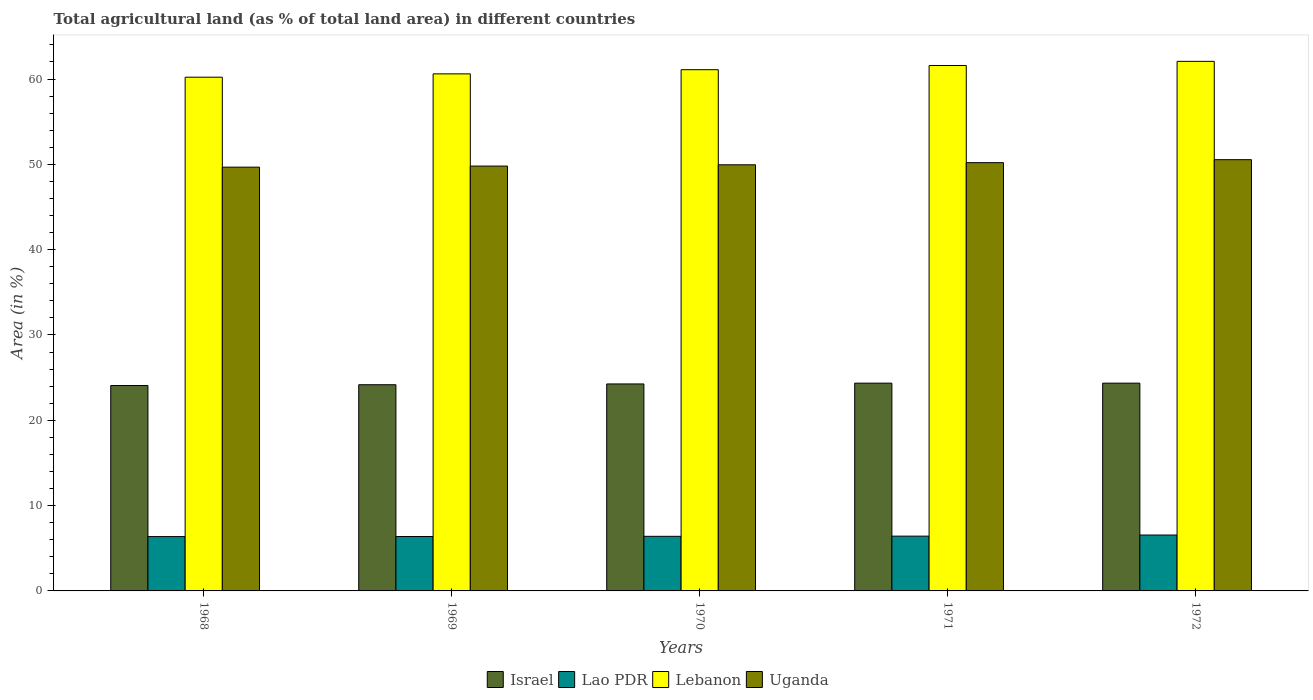How many groups of bars are there?
Provide a succinct answer. 5. Are the number of bars on each tick of the X-axis equal?
Offer a very short reply. Yes. How many bars are there on the 4th tick from the left?
Ensure brevity in your answer.  4. How many bars are there on the 5th tick from the right?
Your response must be concise. 4. In how many cases, is the number of bars for a given year not equal to the number of legend labels?
Offer a terse response. 0. What is the percentage of agricultural land in Uganda in 1972?
Give a very brief answer. 50.55. Across all years, what is the maximum percentage of agricultural land in Israel?
Give a very brief answer. 24.35. Across all years, what is the minimum percentage of agricultural land in Uganda?
Keep it short and to the point. 49.67. In which year was the percentage of agricultural land in Uganda maximum?
Your response must be concise. 1972. In which year was the percentage of agricultural land in Lebanon minimum?
Offer a very short reply. 1968. What is the total percentage of agricultural land in Israel in the graph?
Offer a very short reply. 121.21. What is the difference between the percentage of agricultural land in Israel in 1969 and that in 1970?
Offer a terse response. -0.09. What is the difference between the percentage of agricultural land in Lao PDR in 1968 and the percentage of agricultural land in Lebanon in 1969?
Your answer should be very brief. -54.24. What is the average percentage of agricultural land in Lao PDR per year?
Give a very brief answer. 6.42. In the year 1969, what is the difference between the percentage of agricultural land in Uganda and percentage of agricultural land in Lebanon?
Provide a succinct answer. -10.81. In how many years, is the percentage of agricultural land in Uganda greater than 58 %?
Give a very brief answer. 0. What is the ratio of the percentage of agricultural land in Israel in 1969 to that in 1971?
Provide a succinct answer. 0.99. Is the percentage of agricultural land in Lao PDR in 1968 less than that in 1969?
Offer a terse response. Yes. Is the difference between the percentage of agricultural land in Uganda in 1968 and 1972 greater than the difference between the percentage of agricultural land in Lebanon in 1968 and 1972?
Offer a very short reply. Yes. What is the difference between the highest and the second highest percentage of agricultural land in Uganda?
Your answer should be very brief. 0.35. What is the difference between the highest and the lowest percentage of agricultural land in Israel?
Give a very brief answer. 0.28. In how many years, is the percentage of agricultural land in Lao PDR greater than the average percentage of agricultural land in Lao PDR taken over all years?
Keep it short and to the point. 1. Is the sum of the percentage of agricultural land in Lebanon in 1968 and 1970 greater than the maximum percentage of agricultural land in Israel across all years?
Ensure brevity in your answer.  Yes. What does the 1st bar from the right in 1969 represents?
Keep it short and to the point. Uganda. Is it the case that in every year, the sum of the percentage of agricultural land in Israel and percentage of agricultural land in Lebanon is greater than the percentage of agricultural land in Uganda?
Your answer should be very brief. Yes. How many years are there in the graph?
Make the answer very short. 5. Are the values on the major ticks of Y-axis written in scientific E-notation?
Your response must be concise. No. Does the graph contain any zero values?
Your response must be concise. No. What is the title of the graph?
Ensure brevity in your answer.  Total agricultural land (as % of total land area) in different countries. Does "Middle income" appear as one of the legend labels in the graph?
Offer a very short reply. No. What is the label or title of the Y-axis?
Make the answer very short. Area (in %). What is the Area (in %) in Israel in 1968?
Your answer should be very brief. 24.08. What is the Area (in %) in Lao PDR in 1968?
Provide a short and direct response. 6.37. What is the Area (in %) of Lebanon in 1968?
Your answer should be very brief. 60.22. What is the Area (in %) of Uganda in 1968?
Provide a short and direct response. 49.67. What is the Area (in %) of Israel in 1969?
Give a very brief answer. 24.17. What is the Area (in %) in Lao PDR in 1969?
Make the answer very short. 6.38. What is the Area (in %) in Lebanon in 1969?
Offer a terse response. 60.61. What is the Area (in %) of Uganda in 1969?
Provide a succinct answer. 49.8. What is the Area (in %) of Israel in 1970?
Make the answer very short. 24.26. What is the Area (in %) of Lao PDR in 1970?
Provide a succinct answer. 6.4. What is the Area (in %) in Lebanon in 1970?
Make the answer very short. 61.09. What is the Area (in %) of Uganda in 1970?
Give a very brief answer. 49.95. What is the Area (in %) of Israel in 1971?
Keep it short and to the point. 24.35. What is the Area (in %) of Lao PDR in 1971?
Your response must be concise. 6.42. What is the Area (in %) in Lebanon in 1971?
Your response must be concise. 61.58. What is the Area (in %) of Uganda in 1971?
Give a very brief answer. 50.2. What is the Area (in %) in Israel in 1972?
Offer a terse response. 24.35. What is the Area (in %) of Lao PDR in 1972?
Your answer should be compact. 6.55. What is the Area (in %) of Lebanon in 1972?
Keep it short and to the point. 62.07. What is the Area (in %) in Uganda in 1972?
Your response must be concise. 50.55. Across all years, what is the maximum Area (in %) of Israel?
Provide a short and direct response. 24.35. Across all years, what is the maximum Area (in %) in Lao PDR?
Your answer should be very brief. 6.55. Across all years, what is the maximum Area (in %) in Lebanon?
Give a very brief answer. 62.07. Across all years, what is the maximum Area (in %) in Uganda?
Give a very brief answer. 50.55. Across all years, what is the minimum Area (in %) of Israel?
Your answer should be very brief. 24.08. Across all years, what is the minimum Area (in %) in Lao PDR?
Your response must be concise. 6.37. Across all years, what is the minimum Area (in %) in Lebanon?
Offer a very short reply. 60.22. Across all years, what is the minimum Area (in %) in Uganda?
Provide a short and direct response. 49.67. What is the total Area (in %) in Israel in the graph?
Offer a terse response. 121.21. What is the total Area (in %) in Lao PDR in the graph?
Make the answer very short. 32.12. What is the total Area (in %) in Lebanon in the graph?
Your response must be concise. 305.57. What is the total Area (in %) of Uganda in the graph?
Give a very brief answer. 250.16. What is the difference between the Area (in %) of Israel in 1968 and that in 1969?
Provide a succinct answer. -0.09. What is the difference between the Area (in %) in Lao PDR in 1968 and that in 1969?
Make the answer very short. -0.01. What is the difference between the Area (in %) of Lebanon in 1968 and that in 1969?
Provide a succinct answer. -0.39. What is the difference between the Area (in %) of Uganda in 1968 and that in 1969?
Ensure brevity in your answer.  -0.13. What is the difference between the Area (in %) in Israel in 1968 and that in 1970?
Offer a very short reply. -0.18. What is the difference between the Area (in %) of Lao PDR in 1968 and that in 1970?
Provide a short and direct response. -0.03. What is the difference between the Area (in %) in Lebanon in 1968 and that in 1970?
Your response must be concise. -0.88. What is the difference between the Area (in %) in Uganda in 1968 and that in 1970?
Provide a succinct answer. -0.28. What is the difference between the Area (in %) in Israel in 1968 and that in 1971?
Your answer should be compact. -0.28. What is the difference between the Area (in %) in Lao PDR in 1968 and that in 1971?
Make the answer very short. -0.05. What is the difference between the Area (in %) of Lebanon in 1968 and that in 1971?
Offer a terse response. -1.37. What is the difference between the Area (in %) in Uganda in 1968 and that in 1971?
Provide a succinct answer. -0.53. What is the difference between the Area (in %) in Israel in 1968 and that in 1972?
Your answer should be very brief. -0.28. What is the difference between the Area (in %) of Lao PDR in 1968 and that in 1972?
Your answer should be very brief. -0.18. What is the difference between the Area (in %) of Lebanon in 1968 and that in 1972?
Ensure brevity in your answer.  -1.86. What is the difference between the Area (in %) in Uganda in 1968 and that in 1972?
Offer a very short reply. -0.88. What is the difference between the Area (in %) in Israel in 1969 and that in 1970?
Your answer should be very brief. -0.09. What is the difference between the Area (in %) in Lao PDR in 1969 and that in 1970?
Provide a succinct answer. -0.02. What is the difference between the Area (in %) of Lebanon in 1969 and that in 1970?
Offer a very short reply. -0.49. What is the difference between the Area (in %) in Uganda in 1969 and that in 1970?
Your answer should be very brief. -0.15. What is the difference between the Area (in %) of Israel in 1969 and that in 1971?
Offer a very short reply. -0.18. What is the difference between the Area (in %) of Lao PDR in 1969 and that in 1971?
Give a very brief answer. -0.04. What is the difference between the Area (in %) of Lebanon in 1969 and that in 1971?
Make the answer very short. -0.98. What is the difference between the Area (in %) in Uganda in 1969 and that in 1971?
Provide a succinct answer. -0.4. What is the difference between the Area (in %) in Israel in 1969 and that in 1972?
Your answer should be compact. -0.18. What is the difference between the Area (in %) in Lao PDR in 1969 and that in 1972?
Provide a succinct answer. -0.17. What is the difference between the Area (in %) of Lebanon in 1969 and that in 1972?
Your answer should be very brief. -1.47. What is the difference between the Area (in %) of Uganda in 1969 and that in 1972?
Make the answer very short. -0.75. What is the difference between the Area (in %) in Israel in 1970 and that in 1971?
Your answer should be very brief. -0.09. What is the difference between the Area (in %) in Lao PDR in 1970 and that in 1971?
Ensure brevity in your answer.  -0.02. What is the difference between the Area (in %) of Lebanon in 1970 and that in 1971?
Provide a short and direct response. -0.49. What is the difference between the Area (in %) of Uganda in 1970 and that in 1971?
Provide a succinct answer. -0.25. What is the difference between the Area (in %) in Israel in 1970 and that in 1972?
Ensure brevity in your answer.  -0.09. What is the difference between the Area (in %) of Lao PDR in 1970 and that in 1972?
Provide a succinct answer. -0.15. What is the difference between the Area (in %) of Lebanon in 1970 and that in 1972?
Your answer should be compact. -0.98. What is the difference between the Area (in %) of Uganda in 1970 and that in 1972?
Provide a short and direct response. -0.6. What is the difference between the Area (in %) in Israel in 1971 and that in 1972?
Provide a short and direct response. 0. What is the difference between the Area (in %) in Lao PDR in 1971 and that in 1972?
Your response must be concise. -0.13. What is the difference between the Area (in %) in Lebanon in 1971 and that in 1972?
Provide a succinct answer. -0.49. What is the difference between the Area (in %) in Uganda in 1971 and that in 1972?
Give a very brief answer. -0.35. What is the difference between the Area (in %) in Israel in 1968 and the Area (in %) in Lao PDR in 1969?
Offer a very short reply. 17.7. What is the difference between the Area (in %) in Israel in 1968 and the Area (in %) in Lebanon in 1969?
Provide a short and direct response. -36.53. What is the difference between the Area (in %) of Israel in 1968 and the Area (in %) of Uganda in 1969?
Provide a short and direct response. -25.72. What is the difference between the Area (in %) in Lao PDR in 1968 and the Area (in %) in Lebanon in 1969?
Keep it short and to the point. -54.24. What is the difference between the Area (in %) in Lao PDR in 1968 and the Area (in %) in Uganda in 1969?
Offer a terse response. -43.43. What is the difference between the Area (in %) of Lebanon in 1968 and the Area (in %) of Uganda in 1969?
Offer a very short reply. 10.42. What is the difference between the Area (in %) in Israel in 1968 and the Area (in %) in Lao PDR in 1970?
Your answer should be compact. 17.68. What is the difference between the Area (in %) in Israel in 1968 and the Area (in %) in Lebanon in 1970?
Make the answer very short. -37.02. What is the difference between the Area (in %) in Israel in 1968 and the Area (in %) in Uganda in 1970?
Provide a succinct answer. -25.87. What is the difference between the Area (in %) of Lao PDR in 1968 and the Area (in %) of Lebanon in 1970?
Provide a succinct answer. -54.73. What is the difference between the Area (in %) of Lao PDR in 1968 and the Area (in %) of Uganda in 1970?
Offer a very short reply. -43.58. What is the difference between the Area (in %) of Lebanon in 1968 and the Area (in %) of Uganda in 1970?
Make the answer very short. 10.27. What is the difference between the Area (in %) of Israel in 1968 and the Area (in %) of Lao PDR in 1971?
Offer a very short reply. 17.65. What is the difference between the Area (in %) of Israel in 1968 and the Area (in %) of Lebanon in 1971?
Ensure brevity in your answer.  -37.51. What is the difference between the Area (in %) of Israel in 1968 and the Area (in %) of Uganda in 1971?
Give a very brief answer. -26.12. What is the difference between the Area (in %) of Lao PDR in 1968 and the Area (in %) of Lebanon in 1971?
Ensure brevity in your answer.  -55.21. What is the difference between the Area (in %) in Lao PDR in 1968 and the Area (in %) in Uganda in 1971?
Offer a very short reply. -43.83. What is the difference between the Area (in %) of Lebanon in 1968 and the Area (in %) of Uganda in 1971?
Make the answer very short. 10.02. What is the difference between the Area (in %) of Israel in 1968 and the Area (in %) of Lao PDR in 1972?
Provide a short and direct response. 17.52. What is the difference between the Area (in %) of Israel in 1968 and the Area (in %) of Lebanon in 1972?
Provide a succinct answer. -38. What is the difference between the Area (in %) of Israel in 1968 and the Area (in %) of Uganda in 1972?
Ensure brevity in your answer.  -26.47. What is the difference between the Area (in %) of Lao PDR in 1968 and the Area (in %) of Lebanon in 1972?
Make the answer very short. -55.7. What is the difference between the Area (in %) in Lao PDR in 1968 and the Area (in %) in Uganda in 1972?
Your answer should be very brief. -44.18. What is the difference between the Area (in %) of Lebanon in 1968 and the Area (in %) of Uganda in 1972?
Your answer should be very brief. 9.67. What is the difference between the Area (in %) of Israel in 1969 and the Area (in %) of Lao PDR in 1970?
Ensure brevity in your answer.  17.77. What is the difference between the Area (in %) in Israel in 1969 and the Area (in %) in Lebanon in 1970?
Provide a short and direct response. -36.93. What is the difference between the Area (in %) in Israel in 1969 and the Area (in %) in Uganda in 1970?
Ensure brevity in your answer.  -25.78. What is the difference between the Area (in %) in Lao PDR in 1969 and the Area (in %) in Lebanon in 1970?
Keep it short and to the point. -54.72. What is the difference between the Area (in %) of Lao PDR in 1969 and the Area (in %) of Uganda in 1970?
Give a very brief answer. -43.57. What is the difference between the Area (in %) in Lebanon in 1969 and the Area (in %) in Uganda in 1970?
Keep it short and to the point. 10.66. What is the difference between the Area (in %) in Israel in 1969 and the Area (in %) in Lao PDR in 1971?
Your response must be concise. 17.75. What is the difference between the Area (in %) of Israel in 1969 and the Area (in %) of Lebanon in 1971?
Offer a terse response. -37.42. What is the difference between the Area (in %) of Israel in 1969 and the Area (in %) of Uganda in 1971?
Your answer should be compact. -26.03. What is the difference between the Area (in %) in Lao PDR in 1969 and the Area (in %) in Lebanon in 1971?
Give a very brief answer. -55.21. What is the difference between the Area (in %) of Lao PDR in 1969 and the Area (in %) of Uganda in 1971?
Your answer should be very brief. -43.82. What is the difference between the Area (in %) of Lebanon in 1969 and the Area (in %) of Uganda in 1971?
Offer a terse response. 10.41. What is the difference between the Area (in %) of Israel in 1969 and the Area (in %) of Lao PDR in 1972?
Provide a short and direct response. 17.62. What is the difference between the Area (in %) of Israel in 1969 and the Area (in %) of Lebanon in 1972?
Give a very brief answer. -37.9. What is the difference between the Area (in %) of Israel in 1969 and the Area (in %) of Uganda in 1972?
Make the answer very short. -26.38. What is the difference between the Area (in %) in Lao PDR in 1969 and the Area (in %) in Lebanon in 1972?
Keep it short and to the point. -55.69. What is the difference between the Area (in %) in Lao PDR in 1969 and the Area (in %) in Uganda in 1972?
Give a very brief answer. -44.17. What is the difference between the Area (in %) in Lebanon in 1969 and the Area (in %) in Uganda in 1972?
Keep it short and to the point. 10.06. What is the difference between the Area (in %) of Israel in 1970 and the Area (in %) of Lao PDR in 1971?
Keep it short and to the point. 17.84. What is the difference between the Area (in %) of Israel in 1970 and the Area (in %) of Lebanon in 1971?
Give a very brief answer. -37.32. What is the difference between the Area (in %) in Israel in 1970 and the Area (in %) in Uganda in 1971?
Give a very brief answer. -25.94. What is the difference between the Area (in %) of Lao PDR in 1970 and the Area (in %) of Lebanon in 1971?
Make the answer very short. -55.18. What is the difference between the Area (in %) in Lao PDR in 1970 and the Area (in %) in Uganda in 1971?
Your answer should be compact. -43.8. What is the difference between the Area (in %) of Lebanon in 1970 and the Area (in %) of Uganda in 1971?
Your answer should be very brief. 10.9. What is the difference between the Area (in %) of Israel in 1970 and the Area (in %) of Lao PDR in 1972?
Offer a terse response. 17.71. What is the difference between the Area (in %) in Israel in 1970 and the Area (in %) in Lebanon in 1972?
Make the answer very short. -37.81. What is the difference between the Area (in %) in Israel in 1970 and the Area (in %) in Uganda in 1972?
Your answer should be compact. -26.29. What is the difference between the Area (in %) of Lao PDR in 1970 and the Area (in %) of Lebanon in 1972?
Your response must be concise. -55.67. What is the difference between the Area (in %) in Lao PDR in 1970 and the Area (in %) in Uganda in 1972?
Provide a short and direct response. -44.15. What is the difference between the Area (in %) of Lebanon in 1970 and the Area (in %) of Uganda in 1972?
Offer a terse response. 10.55. What is the difference between the Area (in %) of Israel in 1971 and the Area (in %) of Lao PDR in 1972?
Provide a succinct answer. 17.8. What is the difference between the Area (in %) of Israel in 1971 and the Area (in %) of Lebanon in 1972?
Your response must be concise. -37.72. What is the difference between the Area (in %) in Israel in 1971 and the Area (in %) in Uganda in 1972?
Offer a very short reply. -26.2. What is the difference between the Area (in %) in Lao PDR in 1971 and the Area (in %) in Lebanon in 1972?
Provide a succinct answer. -55.65. What is the difference between the Area (in %) in Lao PDR in 1971 and the Area (in %) in Uganda in 1972?
Your answer should be very brief. -44.13. What is the difference between the Area (in %) in Lebanon in 1971 and the Area (in %) in Uganda in 1972?
Your answer should be compact. 11.04. What is the average Area (in %) of Israel per year?
Provide a short and direct response. 24.24. What is the average Area (in %) of Lao PDR per year?
Your answer should be very brief. 6.42. What is the average Area (in %) in Lebanon per year?
Make the answer very short. 61.11. What is the average Area (in %) of Uganda per year?
Offer a very short reply. 50.03. In the year 1968, what is the difference between the Area (in %) of Israel and Area (in %) of Lao PDR?
Keep it short and to the point. 17.71. In the year 1968, what is the difference between the Area (in %) of Israel and Area (in %) of Lebanon?
Keep it short and to the point. -36.14. In the year 1968, what is the difference between the Area (in %) of Israel and Area (in %) of Uganda?
Ensure brevity in your answer.  -25.6. In the year 1968, what is the difference between the Area (in %) in Lao PDR and Area (in %) in Lebanon?
Provide a succinct answer. -53.85. In the year 1968, what is the difference between the Area (in %) in Lao PDR and Area (in %) in Uganda?
Provide a succinct answer. -43.3. In the year 1968, what is the difference between the Area (in %) in Lebanon and Area (in %) in Uganda?
Provide a succinct answer. 10.54. In the year 1969, what is the difference between the Area (in %) of Israel and Area (in %) of Lao PDR?
Offer a very short reply. 17.79. In the year 1969, what is the difference between the Area (in %) of Israel and Area (in %) of Lebanon?
Make the answer very short. -36.44. In the year 1969, what is the difference between the Area (in %) in Israel and Area (in %) in Uganda?
Your answer should be compact. -25.63. In the year 1969, what is the difference between the Area (in %) in Lao PDR and Area (in %) in Lebanon?
Your response must be concise. -54.23. In the year 1969, what is the difference between the Area (in %) of Lao PDR and Area (in %) of Uganda?
Your answer should be very brief. -43.42. In the year 1969, what is the difference between the Area (in %) in Lebanon and Area (in %) in Uganda?
Keep it short and to the point. 10.81. In the year 1970, what is the difference between the Area (in %) of Israel and Area (in %) of Lao PDR?
Your answer should be compact. 17.86. In the year 1970, what is the difference between the Area (in %) in Israel and Area (in %) in Lebanon?
Your answer should be compact. -36.83. In the year 1970, what is the difference between the Area (in %) in Israel and Area (in %) in Uganda?
Your answer should be very brief. -25.69. In the year 1970, what is the difference between the Area (in %) in Lao PDR and Area (in %) in Lebanon?
Provide a short and direct response. -54.7. In the year 1970, what is the difference between the Area (in %) in Lao PDR and Area (in %) in Uganda?
Keep it short and to the point. -43.55. In the year 1970, what is the difference between the Area (in %) of Lebanon and Area (in %) of Uganda?
Make the answer very short. 11.15. In the year 1971, what is the difference between the Area (in %) in Israel and Area (in %) in Lao PDR?
Offer a very short reply. 17.93. In the year 1971, what is the difference between the Area (in %) in Israel and Area (in %) in Lebanon?
Provide a short and direct response. -37.23. In the year 1971, what is the difference between the Area (in %) in Israel and Area (in %) in Uganda?
Offer a terse response. -25.84. In the year 1971, what is the difference between the Area (in %) of Lao PDR and Area (in %) of Lebanon?
Offer a terse response. -55.16. In the year 1971, what is the difference between the Area (in %) of Lao PDR and Area (in %) of Uganda?
Give a very brief answer. -43.78. In the year 1971, what is the difference between the Area (in %) of Lebanon and Area (in %) of Uganda?
Your answer should be compact. 11.39. In the year 1972, what is the difference between the Area (in %) of Israel and Area (in %) of Lao PDR?
Give a very brief answer. 17.8. In the year 1972, what is the difference between the Area (in %) of Israel and Area (in %) of Lebanon?
Give a very brief answer. -37.72. In the year 1972, what is the difference between the Area (in %) of Israel and Area (in %) of Uganda?
Keep it short and to the point. -26.2. In the year 1972, what is the difference between the Area (in %) in Lao PDR and Area (in %) in Lebanon?
Offer a very short reply. -55.52. In the year 1972, what is the difference between the Area (in %) in Lao PDR and Area (in %) in Uganda?
Your answer should be compact. -44. In the year 1972, what is the difference between the Area (in %) of Lebanon and Area (in %) of Uganda?
Ensure brevity in your answer.  11.52. What is the ratio of the Area (in %) in Lao PDR in 1968 to that in 1969?
Your answer should be compact. 1. What is the ratio of the Area (in %) of Lebanon in 1968 to that in 1969?
Your response must be concise. 0.99. What is the ratio of the Area (in %) in Lao PDR in 1968 to that in 1970?
Your answer should be very brief. 1. What is the ratio of the Area (in %) in Lebanon in 1968 to that in 1970?
Provide a succinct answer. 0.99. What is the ratio of the Area (in %) in Israel in 1968 to that in 1971?
Offer a very short reply. 0.99. What is the ratio of the Area (in %) in Lebanon in 1968 to that in 1971?
Provide a short and direct response. 0.98. What is the ratio of the Area (in %) of Uganda in 1968 to that in 1971?
Give a very brief answer. 0.99. What is the ratio of the Area (in %) of Israel in 1968 to that in 1972?
Provide a succinct answer. 0.99. What is the ratio of the Area (in %) of Lao PDR in 1968 to that in 1972?
Offer a very short reply. 0.97. What is the ratio of the Area (in %) of Lebanon in 1968 to that in 1972?
Make the answer very short. 0.97. What is the ratio of the Area (in %) of Uganda in 1968 to that in 1972?
Provide a succinct answer. 0.98. What is the ratio of the Area (in %) of Israel in 1969 to that in 1970?
Ensure brevity in your answer.  1. What is the ratio of the Area (in %) of Lao PDR in 1969 to that in 1970?
Offer a very short reply. 1. What is the ratio of the Area (in %) of Uganda in 1969 to that in 1970?
Offer a terse response. 1. What is the ratio of the Area (in %) of Israel in 1969 to that in 1971?
Ensure brevity in your answer.  0.99. What is the ratio of the Area (in %) of Lao PDR in 1969 to that in 1971?
Offer a terse response. 0.99. What is the ratio of the Area (in %) of Lebanon in 1969 to that in 1971?
Provide a succinct answer. 0.98. What is the ratio of the Area (in %) in Israel in 1969 to that in 1972?
Your response must be concise. 0.99. What is the ratio of the Area (in %) of Lao PDR in 1969 to that in 1972?
Offer a terse response. 0.97. What is the ratio of the Area (in %) in Lebanon in 1969 to that in 1972?
Offer a very short reply. 0.98. What is the ratio of the Area (in %) of Uganda in 1969 to that in 1972?
Give a very brief answer. 0.99. What is the ratio of the Area (in %) in Uganda in 1970 to that in 1971?
Give a very brief answer. 0.99. What is the ratio of the Area (in %) of Israel in 1970 to that in 1972?
Ensure brevity in your answer.  1. What is the ratio of the Area (in %) in Lao PDR in 1970 to that in 1972?
Make the answer very short. 0.98. What is the ratio of the Area (in %) of Lebanon in 1970 to that in 1972?
Offer a terse response. 0.98. What is the ratio of the Area (in %) of Israel in 1971 to that in 1972?
Make the answer very short. 1. What is the ratio of the Area (in %) of Lao PDR in 1971 to that in 1972?
Ensure brevity in your answer.  0.98. What is the difference between the highest and the second highest Area (in %) in Israel?
Offer a very short reply. 0. What is the difference between the highest and the second highest Area (in %) of Lao PDR?
Give a very brief answer. 0.13. What is the difference between the highest and the second highest Area (in %) in Lebanon?
Offer a terse response. 0.49. What is the difference between the highest and the second highest Area (in %) of Uganda?
Provide a short and direct response. 0.35. What is the difference between the highest and the lowest Area (in %) in Israel?
Ensure brevity in your answer.  0.28. What is the difference between the highest and the lowest Area (in %) of Lao PDR?
Provide a succinct answer. 0.18. What is the difference between the highest and the lowest Area (in %) of Lebanon?
Your answer should be compact. 1.86. What is the difference between the highest and the lowest Area (in %) of Uganda?
Offer a very short reply. 0.88. 